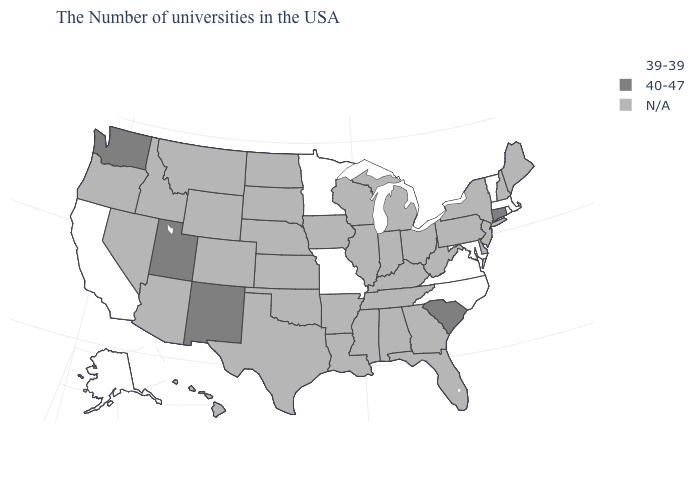Among the states that border Nebraska , which have the lowest value?
Give a very brief answer. Missouri. Which states have the lowest value in the West?
Short answer required. California, Alaska. Name the states that have a value in the range 39-39?
Keep it brief. Massachusetts, Rhode Island, Vermont, Maryland, Virginia, North Carolina, Missouri, Minnesota, California, Alaska. What is the value of Mississippi?
Short answer required. N/A. What is the lowest value in the USA?
Short answer required. 39-39. Name the states that have a value in the range 39-39?
Concise answer only. Massachusetts, Rhode Island, Vermont, Maryland, Virginia, North Carolina, Missouri, Minnesota, California, Alaska. Name the states that have a value in the range 39-39?
Give a very brief answer. Massachusetts, Rhode Island, Vermont, Maryland, Virginia, North Carolina, Missouri, Minnesota, California, Alaska. What is the value of Delaware?
Be succinct. N/A. Name the states that have a value in the range 39-39?
Short answer required. Massachusetts, Rhode Island, Vermont, Maryland, Virginia, North Carolina, Missouri, Minnesota, California, Alaska. Does the map have missing data?
Concise answer only. Yes. Among the states that border Arizona , which have the highest value?
Quick response, please. New Mexico, Utah. 